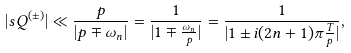<formula> <loc_0><loc_0><loc_500><loc_500>| s Q ^ { ( \pm ) } | \ll \frac { p } { | p \mp \omega _ { n } | } = \frac { 1 } { | 1 \mp \frac { \omega _ { n } } { p } | } = \frac { 1 } { | 1 \pm i ( 2 n + 1 ) \pi \frac { T } { p } | } ,</formula> 